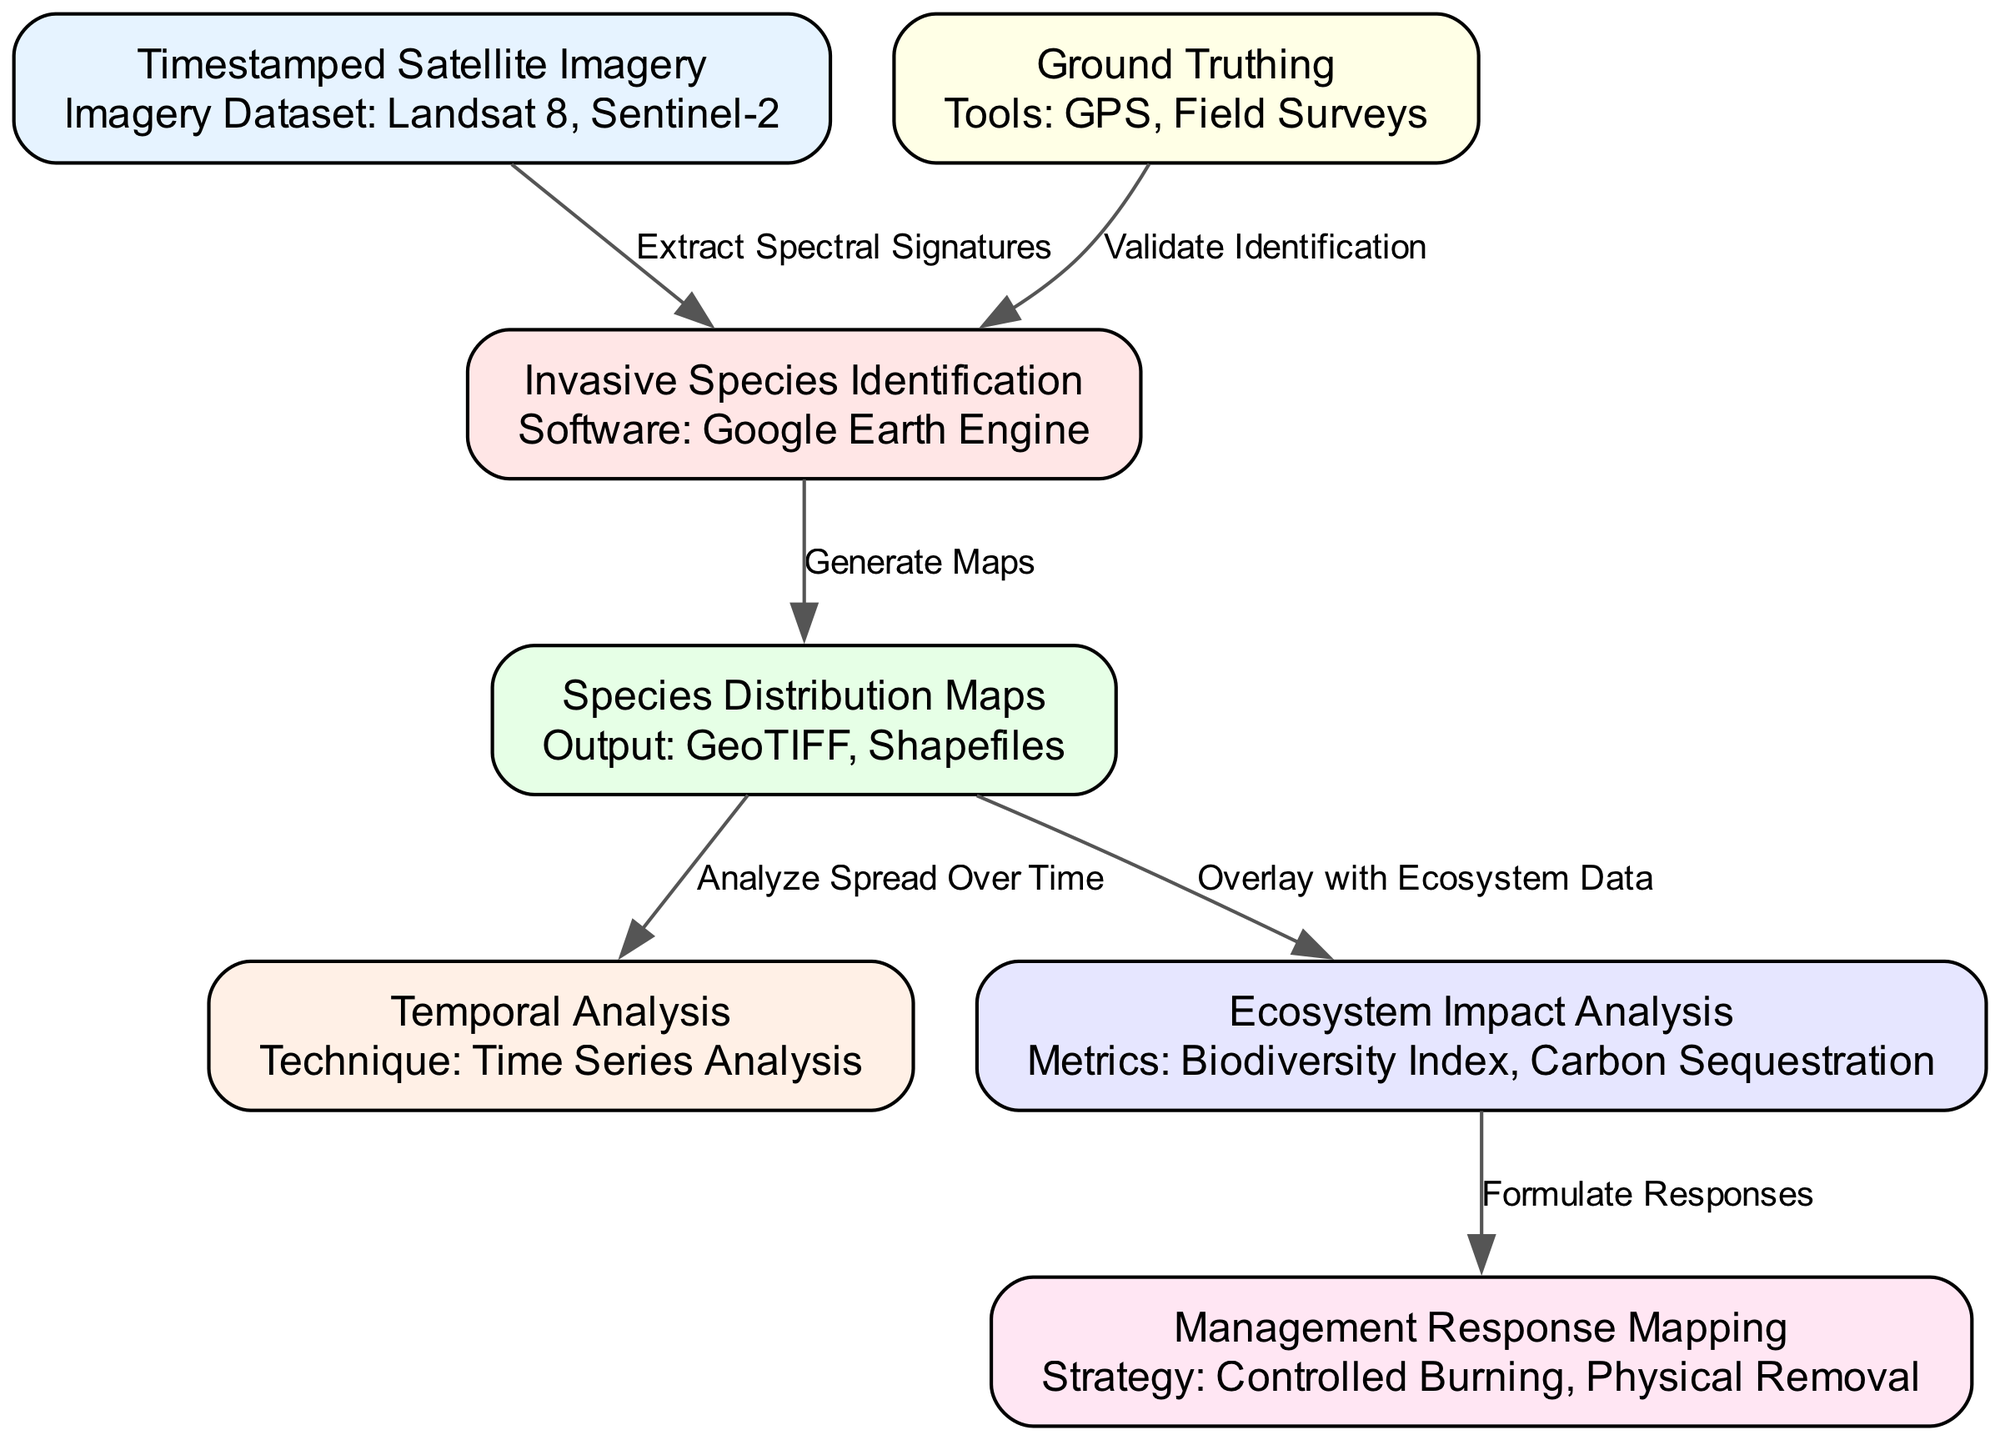What is the timestamped imagery source used in the diagram? The diagram specifies that the timestamped satellite imagery comes from Landsat 8 and Sentinel-2 datasets. This information is found in the node labeled "Timestamped Satellite Imagery."
Answer: Landsat 8, Sentinel-2 How many nodes are present in the diagram? By counting the nodes listed in the diagram, there are a total of seven nodes that correspond to the various components of the analysis provided.
Answer: 7 What kind of maps are generated from invasive species identification? The invasive species identification leads to the production of species distribution maps; this connection is shown in the directed edge between these two nodes.
Answer: Species Distribution Maps Which node is responsible for validating the identification of invasive species? The ground truthing node is specifically identified as using GPS and field surveys to validate the invasive species identification, making it crucial for accuracy in the analysis.
Answer: Ground Truthing What is the technique used for temporal analysis in the diagram? As mentioned in the node labeled "Temporal Analysis," the technique applied for understanding the spread over time is time series analysis, directly relating to the analysis over time of the species' distribution.
Answer: Time Series Analysis How does ecosystem impact analysis relate to response mapping? The ecosystem impact analysis is linked to management response mapping through the formulation of responses based on metrics such as biodiversity index and carbon sequestration provided in the ecosystem analysis.
Answer: Formulate Responses What type of tools are utilized for ground truthing? Ground truthing uses GPS and field surveys as tools, explicitly mentioned in the details of the ground truthing node, which help in validating the identification of invasive species.
Answer: GPS, Field Surveys Which component does the species distribution maps influence by analyzing spread over time? The species distribution maps have a direct influence on the temporal analysis, allowing researchers to assess how the spread of invasive species changes over time. This linkage is explicitly drawn in the edge between these two nodes.
Answer: Temporal Analysis What is analyzed alongside species distribution according to the diagram? The ecosystem impact is analyzed in conjunction with species distribution maps, as the edge indicates an overlay with ecosystem data for understanding the broader ecological implications.
Answer: Ecosystem Impact Analysis 